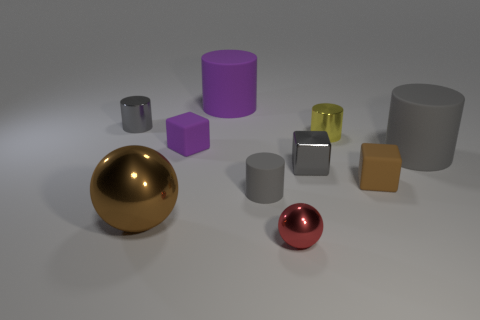Subtract all gray cylinders. How many were subtracted if there are1gray cylinders left? 2 Subtract all blue spheres. How many gray cylinders are left? 3 Subtract all tiny rubber cylinders. How many cylinders are left? 4 Subtract all yellow cylinders. How many cylinders are left? 4 Subtract all brown cylinders. Subtract all green blocks. How many cylinders are left? 5 Subtract all spheres. How many objects are left? 8 Add 6 large shiny balls. How many large shiny balls are left? 7 Add 8 small brown matte cubes. How many small brown matte cubes exist? 9 Subtract 0 blue spheres. How many objects are left? 10 Subtract all yellow cylinders. Subtract all purple cylinders. How many objects are left? 8 